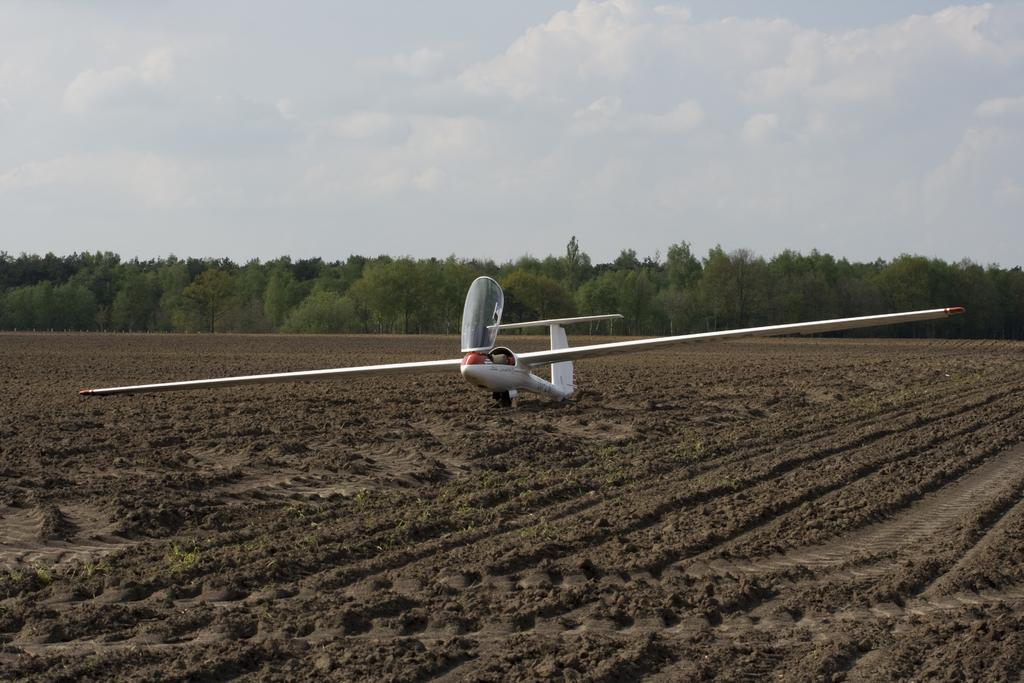What is the main subject of the image? The main subject of the image is a plane. What can be seen in the background of the image? There are trees and clouds in the background of the image. What type of writer can be seen in the image? There is no writer present in the image; it features a plane and a background with trees and clouds. 